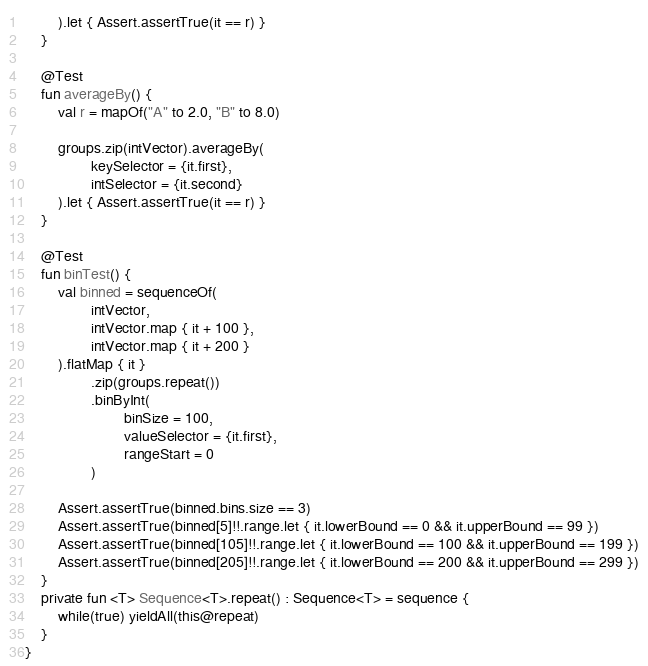Convert code to text. <code><loc_0><loc_0><loc_500><loc_500><_Kotlin_>        ).let { Assert.assertTrue(it == r) }
    }

    @Test
    fun averageBy() {
        val r = mapOf("A" to 2.0, "B" to 8.0)

        groups.zip(intVector).averageBy(
                keySelector = {it.first},
                intSelector = {it.second}
        ).let { Assert.assertTrue(it == r) }
    }

    @Test
    fun binTest() {
        val binned = sequenceOf(
                intVector,
                intVector.map { it + 100 },
                intVector.map { it + 200 }
        ).flatMap { it }
                .zip(groups.repeat())
                .binByInt(
                        binSize = 100,
                        valueSelector = {it.first},
                        rangeStart = 0
                )

        Assert.assertTrue(binned.bins.size == 3)
        Assert.assertTrue(binned[5]!!.range.let { it.lowerBound == 0 && it.upperBound == 99 })
        Assert.assertTrue(binned[105]!!.range.let { it.lowerBound == 100 && it.upperBound == 199 })
        Assert.assertTrue(binned[205]!!.range.let { it.lowerBound == 200 && it.upperBound == 299 })
    }
    private fun <T> Sequence<T>.repeat() : Sequence<T> = sequence {
        while(true) yieldAll(this@repeat)
    }
}


</code> 